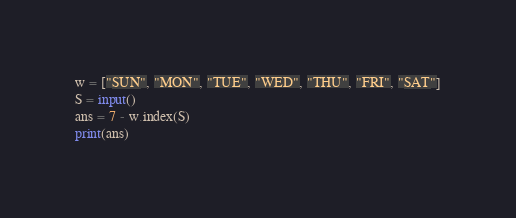<code> <loc_0><loc_0><loc_500><loc_500><_Python_>w = ["SUN", "MON", "TUE", "WED", "THU", "FRI", "SAT"]
S = input()
ans = 7 - w.index(S)
print(ans)</code> 